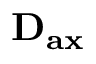<formula> <loc_0><loc_0><loc_500><loc_500>D _ { a x }</formula> 